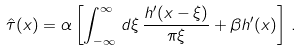<formula> <loc_0><loc_0><loc_500><loc_500>\hat { \tau } ( x ) = \alpha \left [ \int _ { - \infty } ^ { \infty } \, d \xi \, \frac { h ^ { \prime } ( x - \xi ) } { \pi \xi } + \beta h ^ { \prime } ( x ) \right ] \, .</formula> 